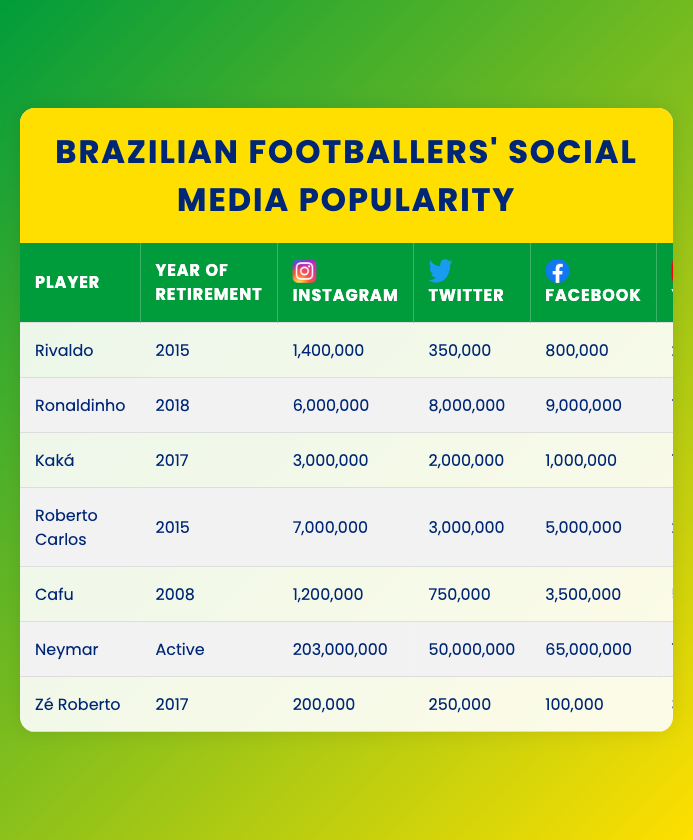What is the highest number of Instagram followers a player has? Looking at the Instagram followers column, Neymar has the highest number with 203,000,000 followers.
Answer: 203,000,000 Which player has the least number of Facebook likes? In the Facebook likes column, Zé Roberto has the least with 100,000 likes.
Answer: 100,000 How many more Twitter followers does Ronaldinho have compared to Rivaldo? Ronaldinho has 8,000,000 Twitter followers and Rivaldo has 350,000. The difference is 8,000,000 - 350,000 = 7,650,000.
Answer: 7,650,000 What is the total number of YouTube subscribers for all players? Summing all YouTube subscribers: 200,000 + 7,000,000 + 100,000 + 250,000 + 50,000 + 7,000,000 + 30,000 = 14,630,000.
Answer: 14,630,000 Which player retired most recently? Among the players, Ronaldinho retired in 2018, which is the most recent year compared to others listed.
Answer: Ronaldinho What percentage of Neymar's Instagram followers does Rivaldo have? Rivaldo has 1,400,000 Instagram followers and Neymar has 203,000,000 followers. To find the percentage: (1,400,000 / 203,000,000) * 100 ≈ 0.69%.
Answer: 0.69% Does Kaká have more Instagram followers than Cafu? Kaká has 3,000,000 Instagram followers while Cafu has 1,200,000. Since 3,000,000 > 1,200,000, the statement is true.
Answer: Yes How many players have more TikTok followers than Zé Roberto? Zé Roberto has 20,000 TikTok followers. Checking the list: Rivaldo (100,000), Ronaldinho (1,500,000), Kaká (500,000), Roberto Carlos (700,000), Cafu (400,000), Neymar (16,000,000) all have more. That totals to 6 players.
Answer: 6 What is the average number of Facebook likes among all players? Total Facebook likes: 800,000 + 9,000,000 + 1,000,000 + 5,000,000 + 3,500,000 + 65,000,000 + 100,000 = 84,400,000. There are 7 players, so average: 84,400,000 / 7 ≈ 12,057,143.
Answer: 12,057,143 Who has more followers combined across all platforms, Rivaldo or Cafu? Rivaldo has 1,400,000 (Instagram) + 350,000 (Twitter) + 800,000 (Facebook) + 200,000 (YouTube) + 100,000 (TikTok) = 2,950,000. Cafu has 1,200,000 + 750,000 + 3,500,000 + 50,000 + 400,000 = 5,900,000. Since 5,900,000 > 2,950,000, Cafu has more.
Answer: Cafu What is the median number of Instagram followers amongst these players? Sorting Instagram followers: 200,000, 1,200,000, 1,400,000, 3,000,000, 6,000,000, 7,000,000, 203,000,000. There are 7 values, the median is the 4th value: 3,000,000.
Answer: 3,000,000 Which platform has the highest average number of followers among all players? Calculating averages: Instagram: (1,400,000 + 6,000,000 + 3,000,000 + 7,000,000 + 1,200,000 + 203,000,000 + 200,000) / 7 = 29,714,286; Twitter: (350,000 + 8,000,000 + 2,000,000 + 3,000,000 + 750,000 + 50,000,000 + 250,000) / 7 = 10,428,571; Facebook: 12,057,143; YouTube: 2,090,000; TikTok: 2,000,000. Instagram has the highest average.
Answer: Instagram 